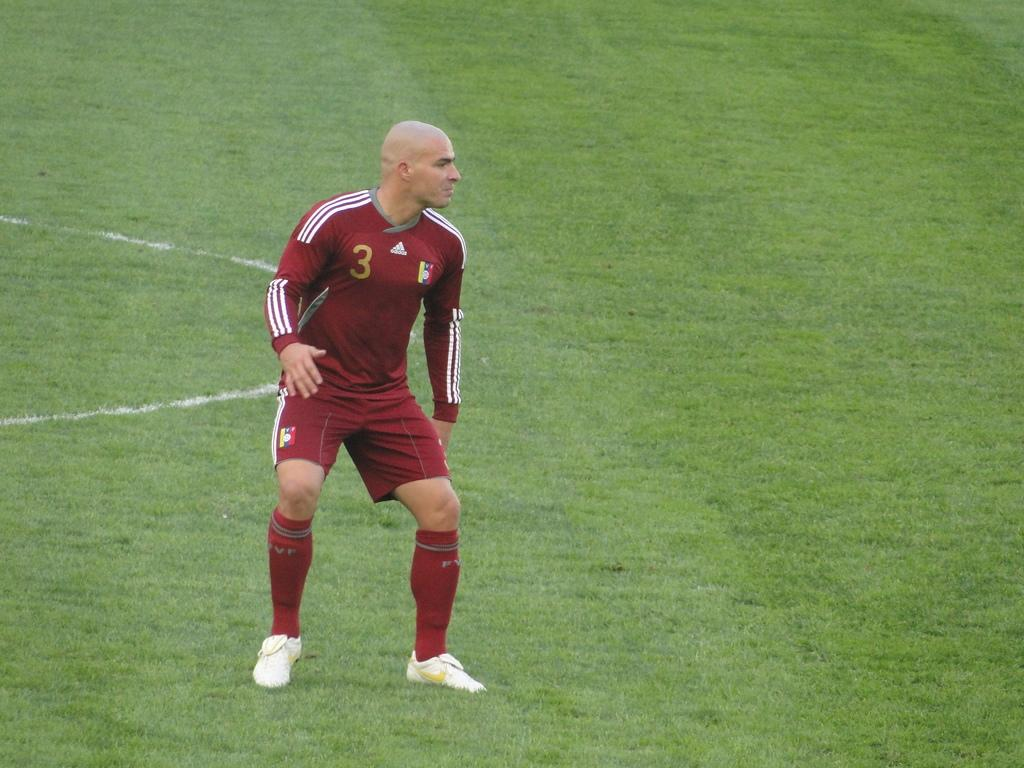What is the main subject of the image? There is a person in the image. What is the person doing in the image? The person is standing. What is the person wearing in the image? The person is wearing a maroon and white color dress and white shoes. What is the person standing on in the image? The person is standing on the ground. What type of boats can be seen in the image? There are no boats present in the image; it features a person standing on the ground. What type of legal advice is the person providing in the image? There is no indication in the image that the person is providing legal advice or acting as a lawyer. 